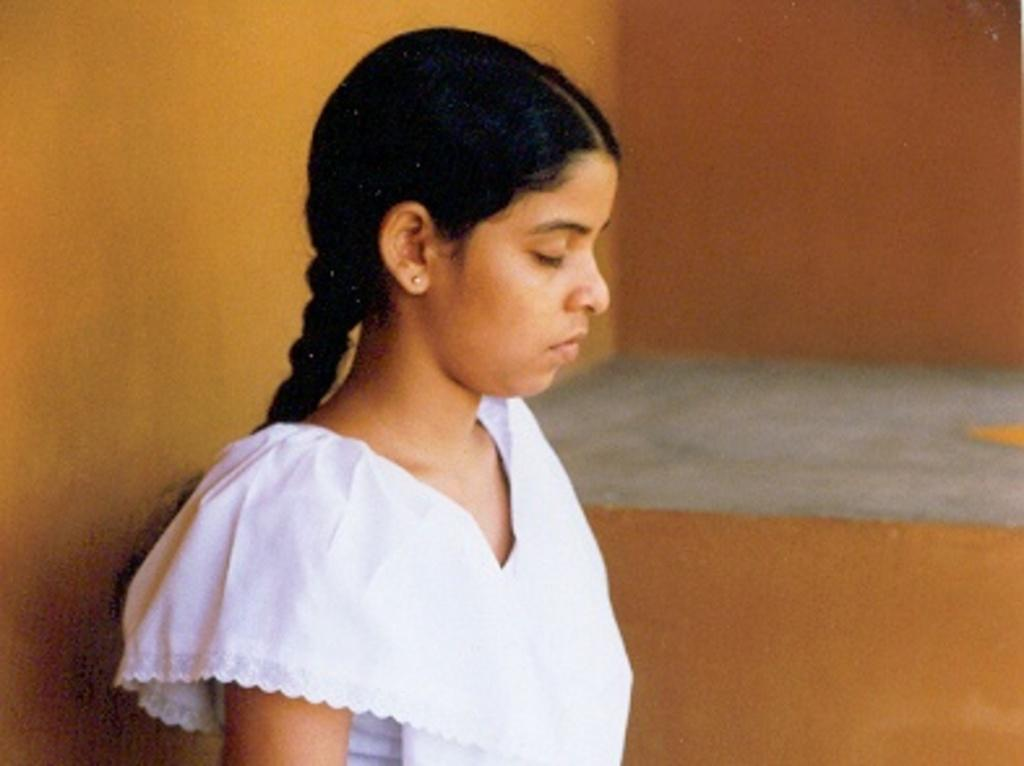Who is the main subject in the image? There is a woman in the image. What is the woman wearing? The woman is wearing a white dress. What is the woman doing in the image? The woman has her eyes closed. In which direction is the woman facing? The woman is facing towards the right side. What can be seen in the background of the image? There is a wall in the background of the image. What type of noise is the woman making in the image? There is no indication of any noise being made by the woman in the image. How many brothers does the woman have in the image? There is no information about the woman's brothers in the image. 